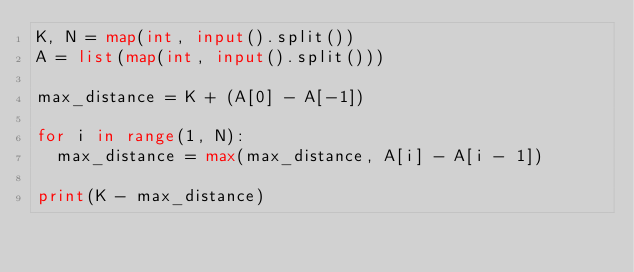Convert code to text. <code><loc_0><loc_0><loc_500><loc_500><_Python_>K, N = map(int, input().split())
A = list(map(int, input().split()))
 
max_distance = K + (A[0] - A[-1])
 
for i in range(1, N):
  max_distance = max(max_distance, A[i] - A[i - 1])
  
print(K - max_distance)</code> 